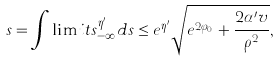Convert formula to latex. <formula><loc_0><loc_0><loc_500><loc_500>s = \int \lim i t s _ { - \infty } ^ { \eta ^ { \prime } } d s \leq e ^ { \eta ^ { \prime } } \sqrt { e ^ { 2 \varphi _ { 0 } } + \frac { 2 \alpha ^ { \prime } v } { \rho ^ { 2 } } } ,</formula> 